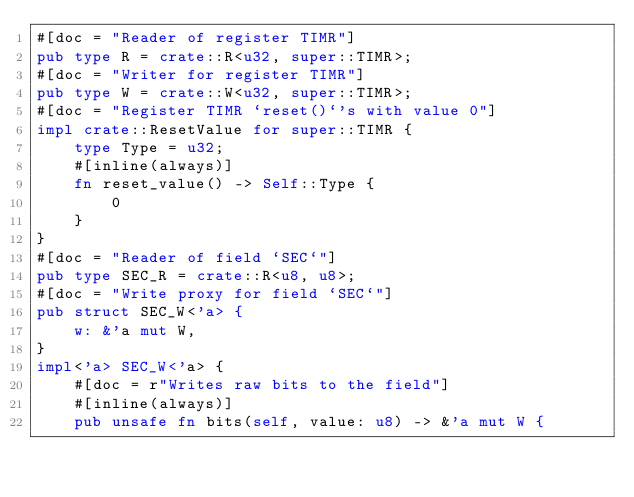<code> <loc_0><loc_0><loc_500><loc_500><_Rust_>#[doc = "Reader of register TIMR"]
pub type R = crate::R<u32, super::TIMR>;
#[doc = "Writer for register TIMR"]
pub type W = crate::W<u32, super::TIMR>;
#[doc = "Register TIMR `reset()`'s with value 0"]
impl crate::ResetValue for super::TIMR {
    type Type = u32;
    #[inline(always)]
    fn reset_value() -> Self::Type {
        0
    }
}
#[doc = "Reader of field `SEC`"]
pub type SEC_R = crate::R<u8, u8>;
#[doc = "Write proxy for field `SEC`"]
pub struct SEC_W<'a> {
    w: &'a mut W,
}
impl<'a> SEC_W<'a> {
    #[doc = r"Writes raw bits to the field"]
    #[inline(always)]
    pub unsafe fn bits(self, value: u8) -> &'a mut W {</code> 